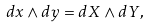<formula> <loc_0><loc_0><loc_500><loc_500>d x \wedge d y = d X \wedge d Y ,</formula> 